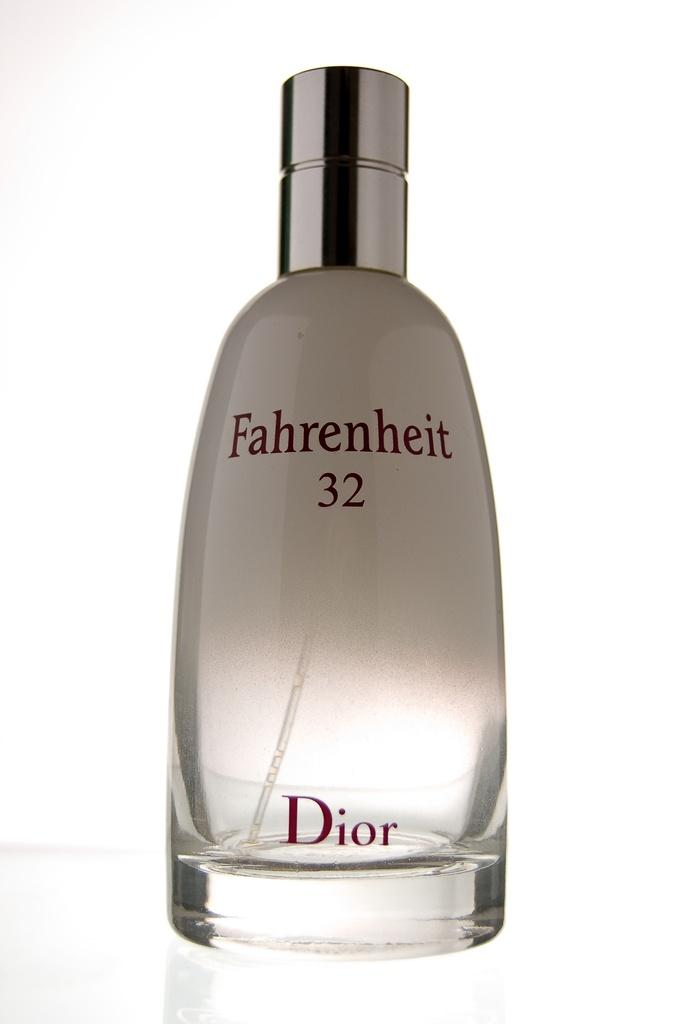Provide a one-sentence caption for the provided image. A clear bottle of Fahrenheit 32 perfume by Dior. 